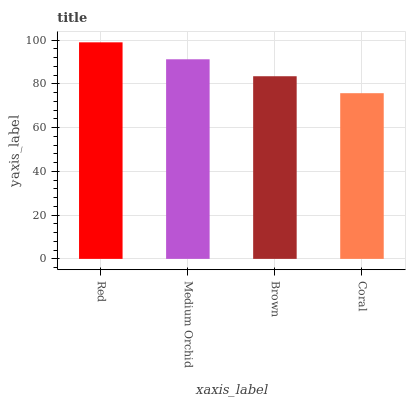Is Coral the minimum?
Answer yes or no. Yes. Is Red the maximum?
Answer yes or no. Yes. Is Medium Orchid the minimum?
Answer yes or no. No. Is Medium Orchid the maximum?
Answer yes or no. No. Is Red greater than Medium Orchid?
Answer yes or no. Yes. Is Medium Orchid less than Red?
Answer yes or no. Yes. Is Medium Orchid greater than Red?
Answer yes or no. No. Is Red less than Medium Orchid?
Answer yes or no. No. Is Medium Orchid the high median?
Answer yes or no. Yes. Is Brown the low median?
Answer yes or no. Yes. Is Red the high median?
Answer yes or no. No. Is Medium Orchid the low median?
Answer yes or no. No. 